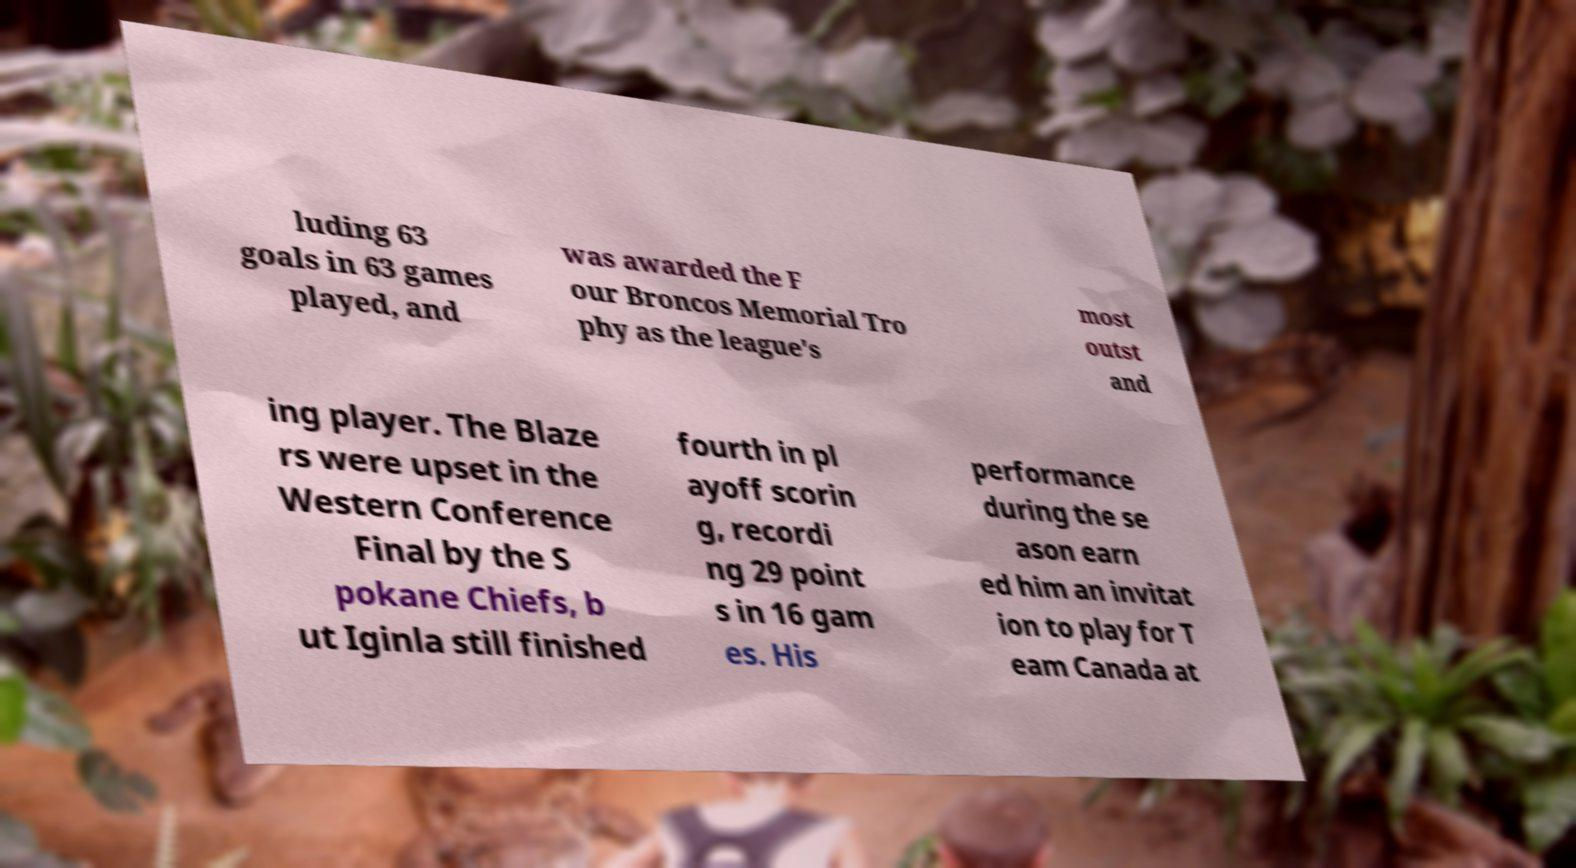There's text embedded in this image that I need extracted. Can you transcribe it verbatim? luding 63 goals in 63 games played, and was awarded the F our Broncos Memorial Tro phy as the league's most outst and ing player. The Blaze rs were upset in the Western Conference Final by the S pokane Chiefs, b ut Iginla still finished fourth in pl ayoff scorin g, recordi ng 29 point s in 16 gam es. His performance during the se ason earn ed him an invitat ion to play for T eam Canada at 